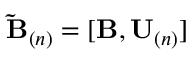Convert formula to latex. <formula><loc_0><loc_0><loc_500><loc_500>\tilde { B } _ { ( n ) } = [ B , U _ { ( n ) } ]</formula> 